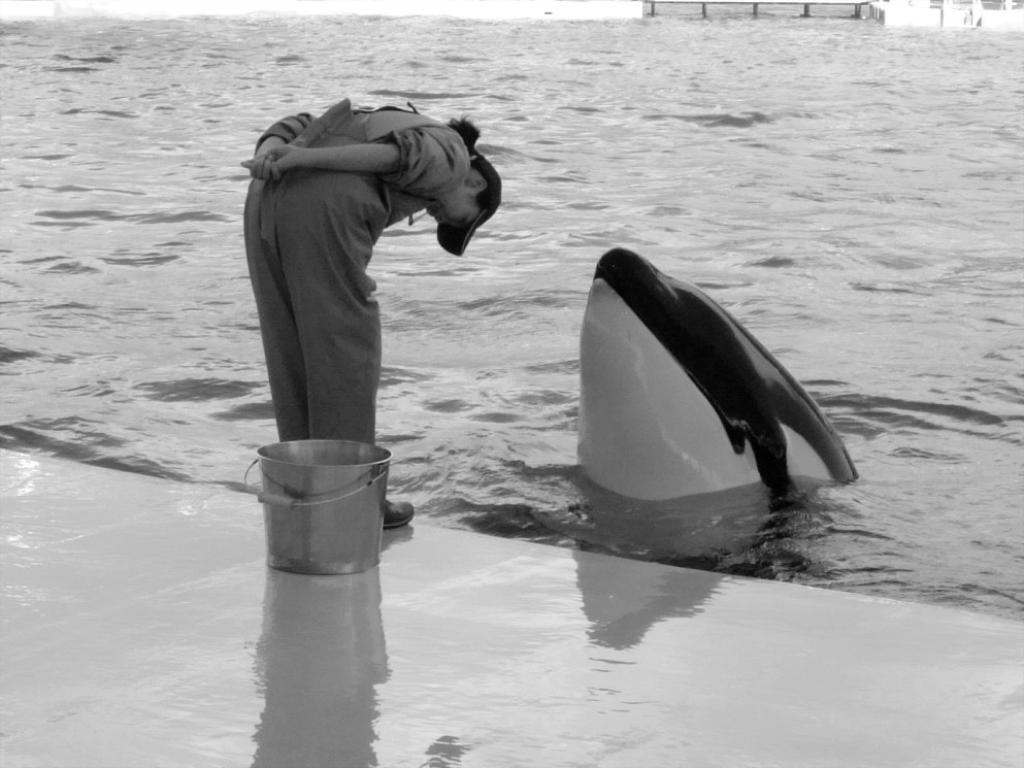What object can be seen in the image? There is a bucket in the image. What is the person in the image doing? The person is standing on the floor in the image. What animal is visible in the water in front of the person? A dolphin is visible in the water in front of the person. What can be seen in the background of the image? There are objects in the background of the image. How many brothers does the dolphin have in the image? There are no brothers mentioned or visible in the image. What question is the person asking the dolphin in the image? There is no indication of a question being asked in the image. 